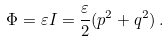Convert formula to latex. <formula><loc_0><loc_0><loc_500><loc_500>\Phi = \varepsilon I = \frac { \varepsilon } { 2 } ( p ^ { 2 } + q ^ { 2 } ) \, .</formula> 